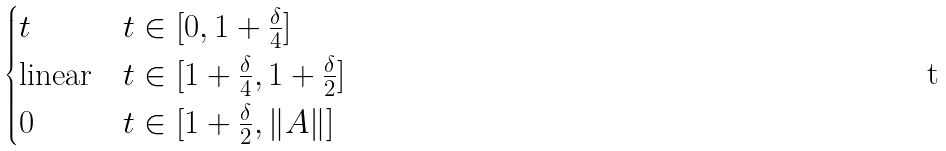<formula> <loc_0><loc_0><loc_500><loc_500>\begin{cases} t \quad & t \in [ 0 , 1 + \frac { \delta } 4 ] \\ \text {linear} & t \in [ 1 + \frac { \delta } 4 , 1 + \frac { \delta } 2 ] \\ 0 & t \in [ 1 + \frac { \delta } 2 , \| A \| ] \end{cases}</formula> 